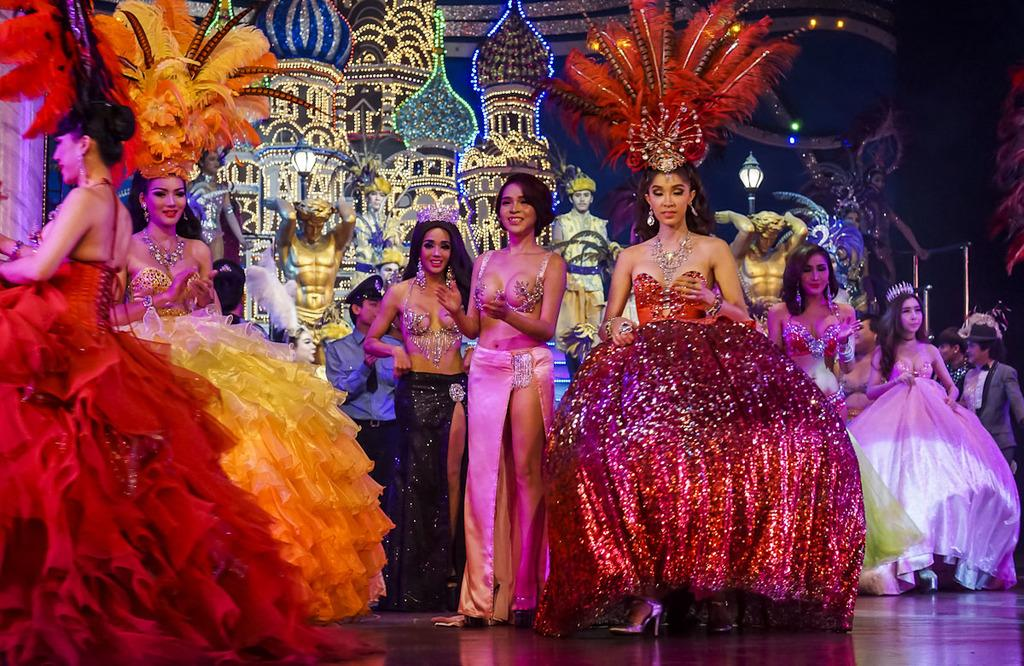What can be observed about the people in the image? There are people standing in the image, and some of them are smiling. What are the people wearing? The people are wearing clothes. What is the setting of the image? There is a floor visible in the image, and there is a light pole and a castle decoration present. What type of brick is used to build the soup in the image? There is no soup or brick present in the image. How does the heat affect the people in the image? The image does not provide any information about the temperature or heat, so it cannot be determined how it affects the people. 